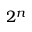<formula> <loc_0><loc_0><loc_500><loc_500>2 ^ { n }</formula> 